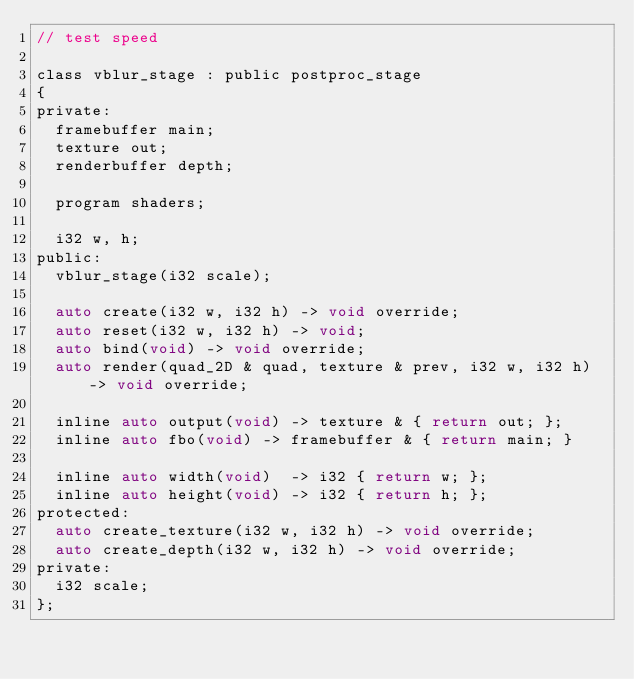Convert code to text. <code><loc_0><loc_0><loc_500><loc_500><_C_>// test speed

class vblur_stage : public postproc_stage
{
private:
	framebuffer main;
	texture out;
	renderbuffer depth;

	program shaders;

	i32 w, h;
public:
	vblur_stage(i32 scale);

	auto create(i32 w, i32 h) -> void override;
	auto reset(i32 w, i32 h) -> void;
	auto bind(void) -> void override;
	auto render(quad_2D & quad, texture & prev, i32 w, i32 h) -> void override;

	inline auto output(void) -> texture & { return out; };
	inline auto fbo(void) -> framebuffer & { return main; }

	inline auto width(void)  -> i32 { return w; };
	inline auto height(void) -> i32 { return h; };
protected:
	auto create_texture(i32 w, i32 h) -> void override;
	auto create_depth(i32 w, i32 h) -> void override;
private:
	i32 scale;
};</code> 